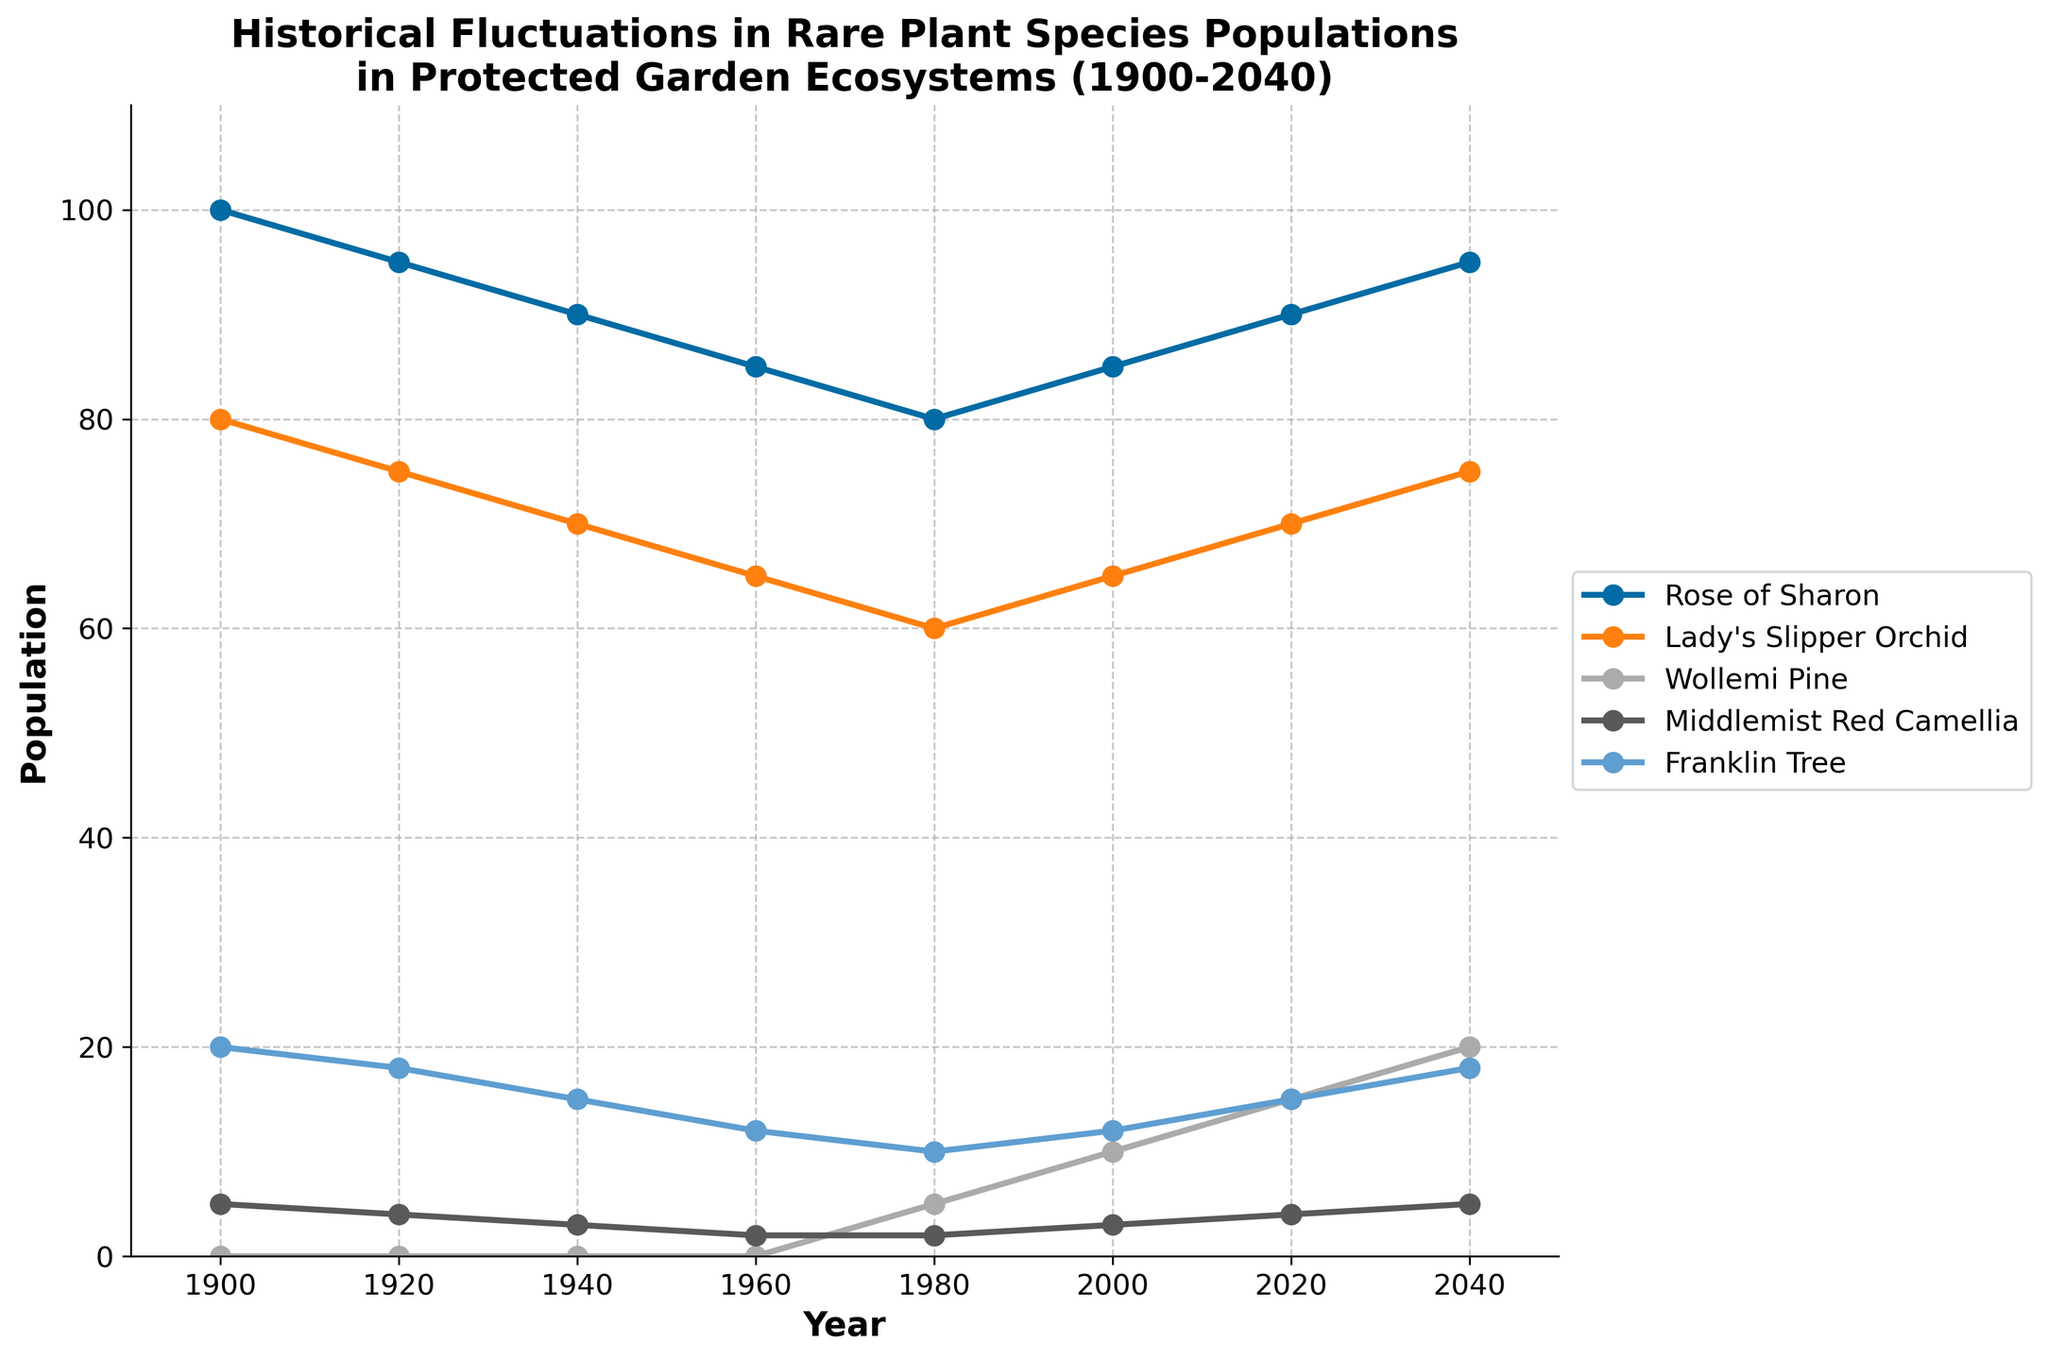What is the population of the Lady's Slipper Orchid in 2020? By examining the figure, find the line and marker representing the Lady's Slipper Orchid in the year 2020. The value at this point is the population.
Answer: 70 Which species showed the greatest increase in population between 1980 and 2040? Look for the species lines between the years 1980 and 2040. Calculate the difference in population for each species and identify the one with the largest increase.
Answer: Wollemi Pine Compare the population of Franklin Tree and Rose of Sharon in 2000. Which one is higher? Identify the data points for the Franklin Tree and Rose of Sharon in the year 2000. Compare their populations visually.
Answer: Rose of Sharon What trend is observed in the population of Middlemist Red Camellia from 1900 to 2040? Follow the line representing Middlemist Red Camellia from 1900 to 2040 and observe the direction of the trend.
Answer: Steady increase Calculate the average population of the Wollemi Pine from 1980 to 2040. Identify the Wollemi Pine's population values for the years 1980, 2000, 2020, and 2040. Add these values together and divide by the number of years. The calculation is (5+10+15+20)/4=12.5.
Answer: 12.5 What is the combined population of Lady's Slipper Orchid and Franklin Tree in 1940? Identify the population values for Lady's Slipper Orchid and Franklin Tree in 1940. Add these values together. The calculation is 70+15=85.
Answer: 85 Which species had a population of 0 until 1980, and then began to increase? Observe each species' line from 1900 to 1980. The species whose population line is at 0 and then starts increasing is the answer.
Answer: Wollemi Pine Compare the populations of Rose of Sharon in 1920 and 2040. What is the difference? Identify the populations of Rose of Sharon in 1920 and 2040. Subtract the value in 1920 from the value in 2040 to find the difference. The calculation is 95-95=0.
Answer: 0 Is there any species whose population remained constant at any point? If so, which species and during what period? Examine lines for flat segments that represent constant population values. Identify if and when any species showed no change.
Answer: Middlemist Red Camellia (1960-1980) 